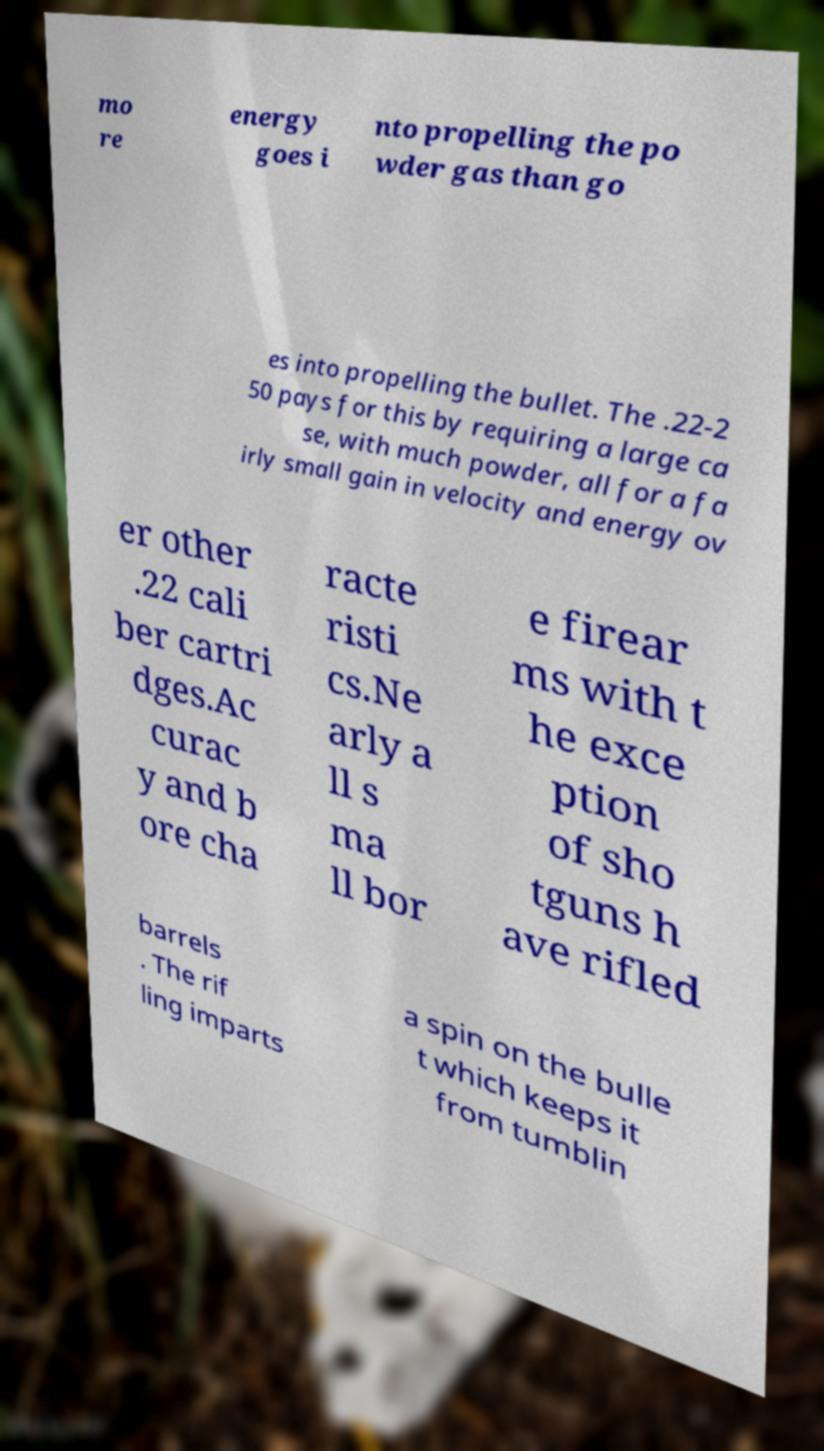Could you assist in decoding the text presented in this image and type it out clearly? mo re energy goes i nto propelling the po wder gas than go es into propelling the bullet. The .22-2 50 pays for this by requiring a large ca se, with much powder, all for a fa irly small gain in velocity and energy ov er other .22 cali ber cartri dges.Ac curac y and b ore cha racte risti cs.Ne arly a ll s ma ll bor e firear ms with t he exce ption of sho tguns h ave rifled barrels . The rif ling imparts a spin on the bulle t which keeps it from tumblin 